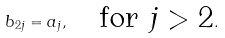<formula> <loc_0><loc_0><loc_500><loc_500>b _ { 2 j } = a _ { j } , \quad \text {for $j>2$} .</formula> 